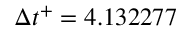<formula> <loc_0><loc_0><loc_500><loc_500>\Delta { t } ^ { + } = 4 . 1 3 2 2 7 7</formula> 